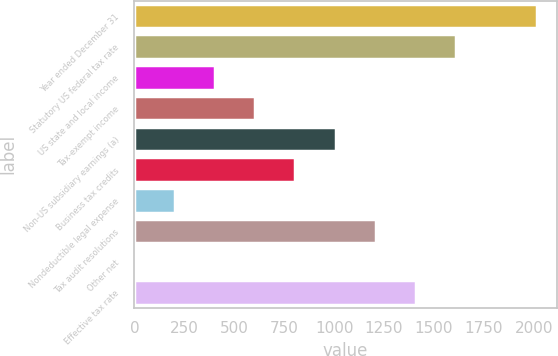Convert chart. <chart><loc_0><loc_0><loc_500><loc_500><bar_chart><fcel>Year ended December 31<fcel>Statutory US federal tax rate<fcel>US state and local income<fcel>Tax-exempt income<fcel>Non-US subsidiary earnings (a)<fcel>Business tax credits<fcel>Nondeductible legal expense<fcel>Tax audit resolutions<fcel>Other net<fcel>Effective tax rate<nl><fcel>2015<fcel>1612.06<fcel>403.24<fcel>604.71<fcel>1007.65<fcel>806.18<fcel>201.77<fcel>1209.12<fcel>0.3<fcel>1410.59<nl></chart> 